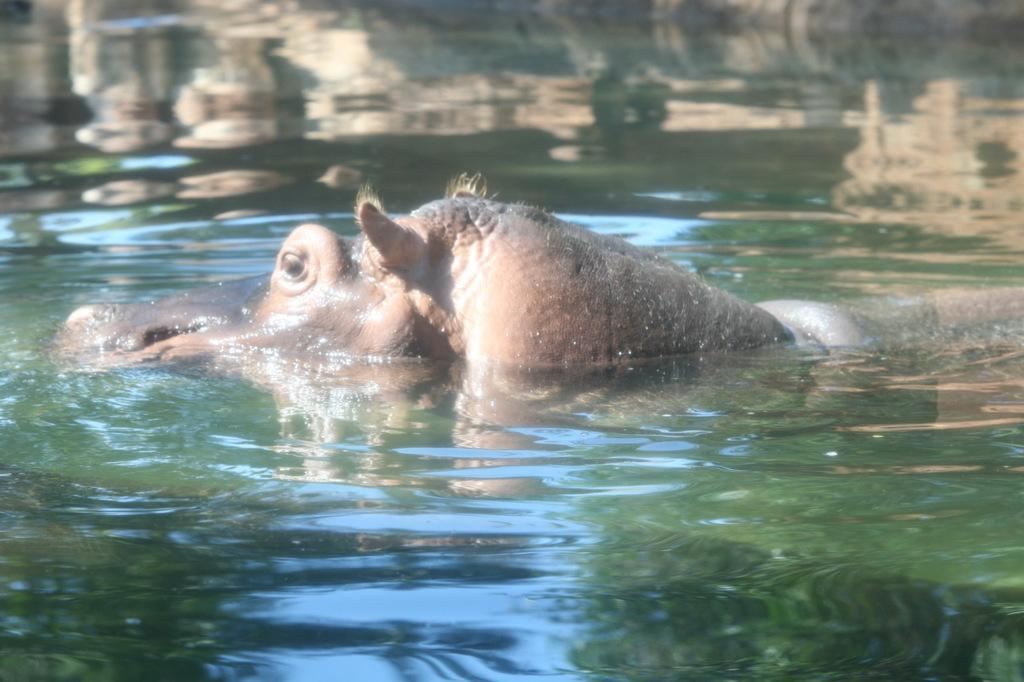What animal is the main subject of the picture? There is a hippopotamus in the picture. What is the hippopotamus doing in the image? The hippopotamus is swimming in the water. What type of noise can be heard coming from the servant in the image? There is no servant present in the image, so it is not possible to determine what noise might be heard. 